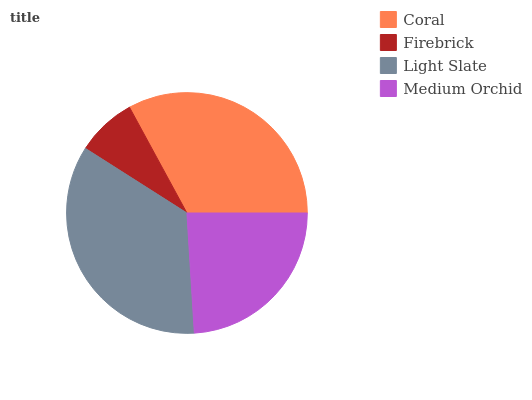Is Firebrick the minimum?
Answer yes or no. Yes. Is Light Slate the maximum?
Answer yes or no. Yes. Is Light Slate the minimum?
Answer yes or no. No. Is Firebrick the maximum?
Answer yes or no. No. Is Light Slate greater than Firebrick?
Answer yes or no. Yes. Is Firebrick less than Light Slate?
Answer yes or no. Yes. Is Firebrick greater than Light Slate?
Answer yes or no. No. Is Light Slate less than Firebrick?
Answer yes or no. No. Is Coral the high median?
Answer yes or no. Yes. Is Medium Orchid the low median?
Answer yes or no. Yes. Is Firebrick the high median?
Answer yes or no. No. Is Firebrick the low median?
Answer yes or no. No. 